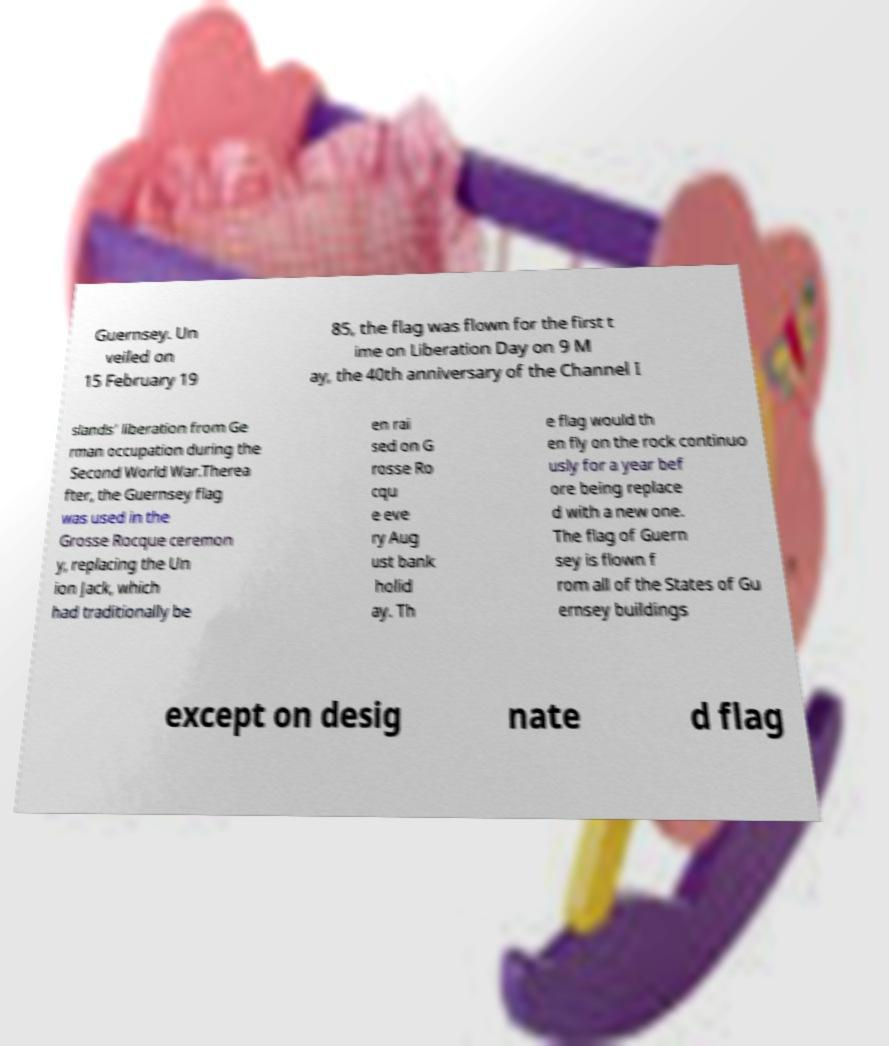Could you assist in decoding the text presented in this image and type it out clearly? Guernsey. Un veiled on 15 February 19 85, the flag was flown for the first t ime on Liberation Day on 9 M ay, the 40th anniversary of the Channel I slands' liberation from Ge rman occupation during the Second World War.Therea fter, the Guernsey flag was used in the Grosse Rocque ceremon y, replacing the Un ion Jack, which had traditionally be en rai sed on G rosse Ro cqu e eve ry Aug ust bank holid ay. Th e flag would th en fly on the rock continuo usly for a year bef ore being replace d with a new one. The flag of Guern sey is flown f rom all of the States of Gu ernsey buildings except on desig nate d flag 